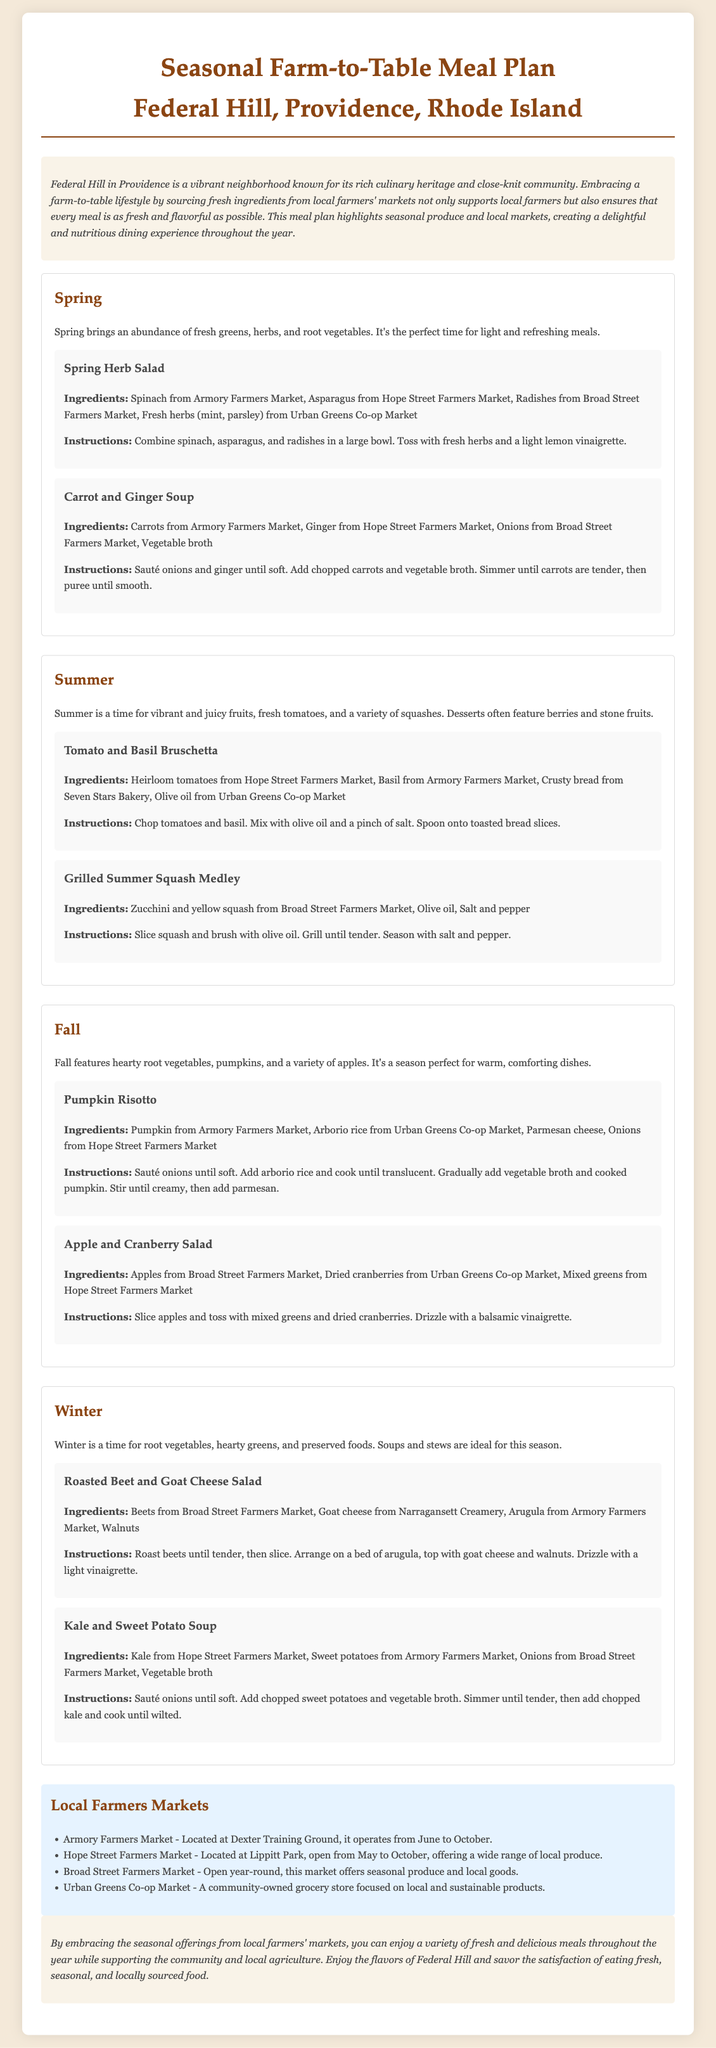What seasonal ingredients are highlighted in the spring meals? The spring meals highlight fresh greens, herbs, and root vegetables.
Answer: greens, herbs, root vegetables Which farm does the recipe for Pumpkin Risotto source its pumpkin from? The recipe for Pumpkin Risotto sources its pumpkin from Armory Farmers Market.
Answer: Armory Farmers Market What are the opening months for Hope Street Farmers Market? Hope Street Farmers Market is open from May to October.
Answer: May to October How many recipes are featured in the summer section? The summer section features two recipes: Tomato and Basil Bruschetta and Grilled Summer Squash Medley.
Answer: Two Which local market is a community-owned grocery store? Urban Greens Co-op Market is a community-owned grocery store focused on local and sustainable products.
Answer: Urban Greens Co-op Market What type of meal is best suited for winter based on the document? The document suggests that soups and stews are ideal meals for winter.
Answer: Soups and stews How many different seasonal sections are included in the meal plan? The meal plan includes four seasonal sections: Spring, Summer, Fall, and Winter.
Answer: Four What type of salad is suggested for autumn? The suggested salad for autumn is Apple and Cranberry Salad.
Answer: Apple and Cranberry Salad 